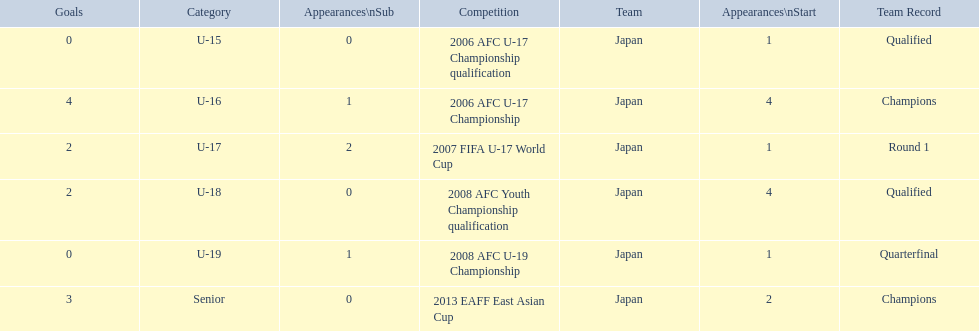Write the full table. {'header': ['Goals', 'Category', 'Appearances\\nSub', 'Competition', 'Team', 'Appearances\\nStart', 'Team Record'], 'rows': [['0', 'U-15', '0', '2006 AFC U-17 Championship qualification', 'Japan', '1', 'Qualified'], ['4', 'U-16', '1', '2006 AFC U-17 Championship', 'Japan', '4', 'Champions'], ['2', 'U-17', '2', '2007 FIFA U-17 World Cup', 'Japan', '1', 'Round 1'], ['2', 'U-18', '0', '2008 AFC Youth Championship qualification', 'Japan', '4', 'Qualified'], ['0', 'U-19', '1', '2008 AFC U-19 Championship', 'Japan', '1', 'Quarterfinal'], ['3', 'Senior', '0', '2013 EAFF East Asian Cup', 'Japan', '2', 'Champions']]} Which competitions had champions team records? 2006 AFC U-17 Championship, 2013 EAFF East Asian Cup. Of these competitions, which one was in the senior category? 2013 EAFF East Asian Cup. 